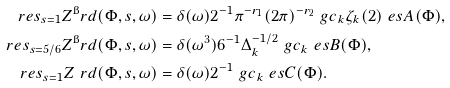Convert formula to latex. <formula><loc_0><loc_0><loc_500><loc_500>\ r e s _ { s = 1 } Z ^ { \i } r d ( \Phi , s , \omega ) & = \delta ( \omega ) 2 ^ { - 1 } \pi ^ { - r _ { 1 } } ( 2 \pi ) ^ { - r _ { 2 } } \ g c _ { k } \zeta _ { k } ( 2 ) \ e s A ( \Phi ) , \\ \ r e s _ { s = 5 / 6 } Z ^ { \i } r d ( \Phi , s , \omega ) & = \delta ( \omega ^ { 3 } ) 6 ^ { - 1 } \Delta _ { k } ^ { - 1 / 2 } \ g c _ { k } \ e s B ( \Phi ) , \\ \ r e s _ { s = 1 } Z ^ { \ } r d ( \Phi , s , \omega ) & = \delta ( \omega ) 2 ^ { - 1 } \ g c _ { k } \ e s C ( \Phi ) .</formula> 